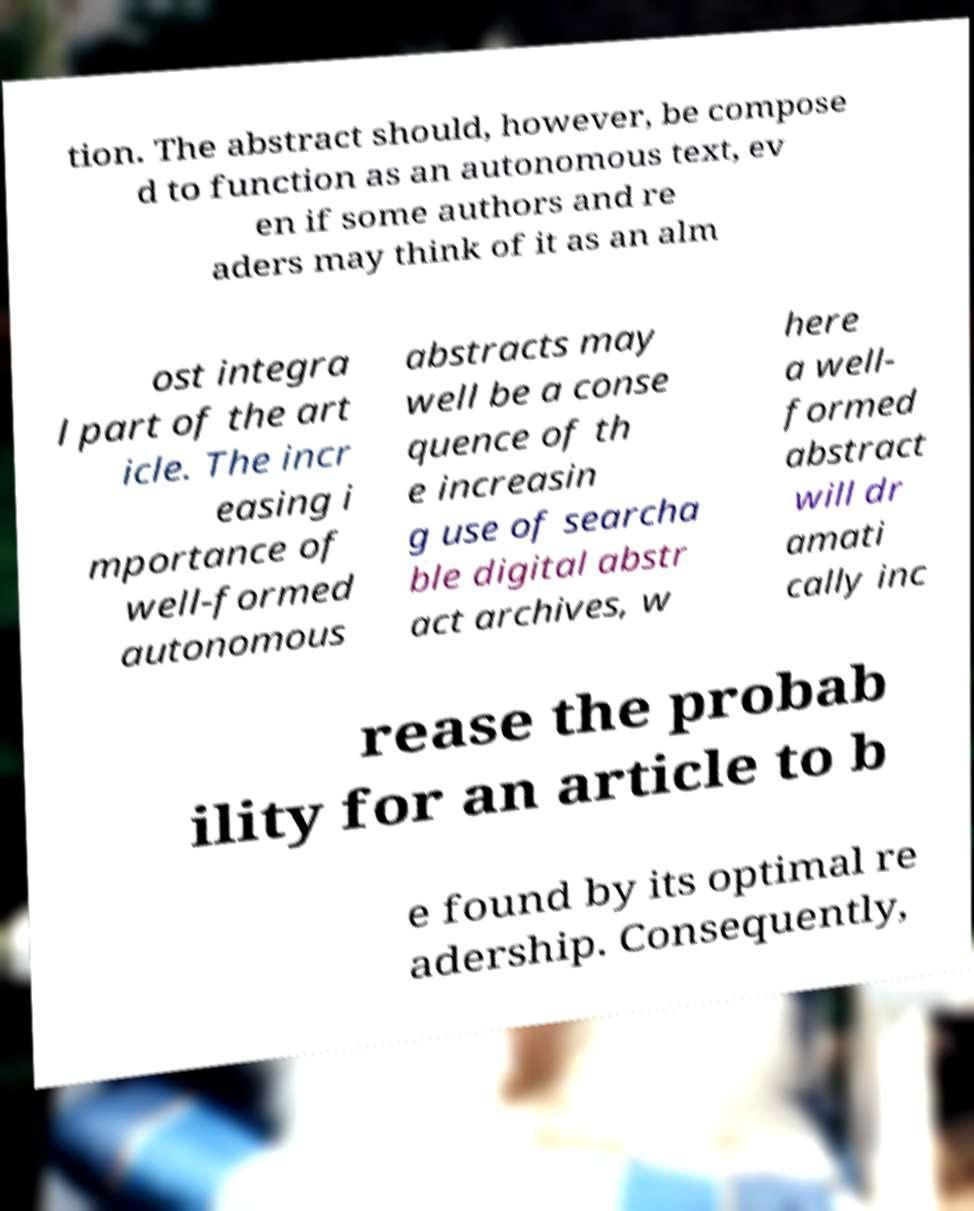Please read and relay the text visible in this image. What does it say? tion. The abstract should, however, be compose d to function as an autonomous text, ev en if some authors and re aders may think of it as an alm ost integra l part of the art icle. The incr easing i mportance of well-formed autonomous abstracts may well be a conse quence of th e increasin g use of searcha ble digital abstr act archives, w here a well- formed abstract will dr amati cally inc rease the probab ility for an article to b e found by its optimal re adership. Consequently, 